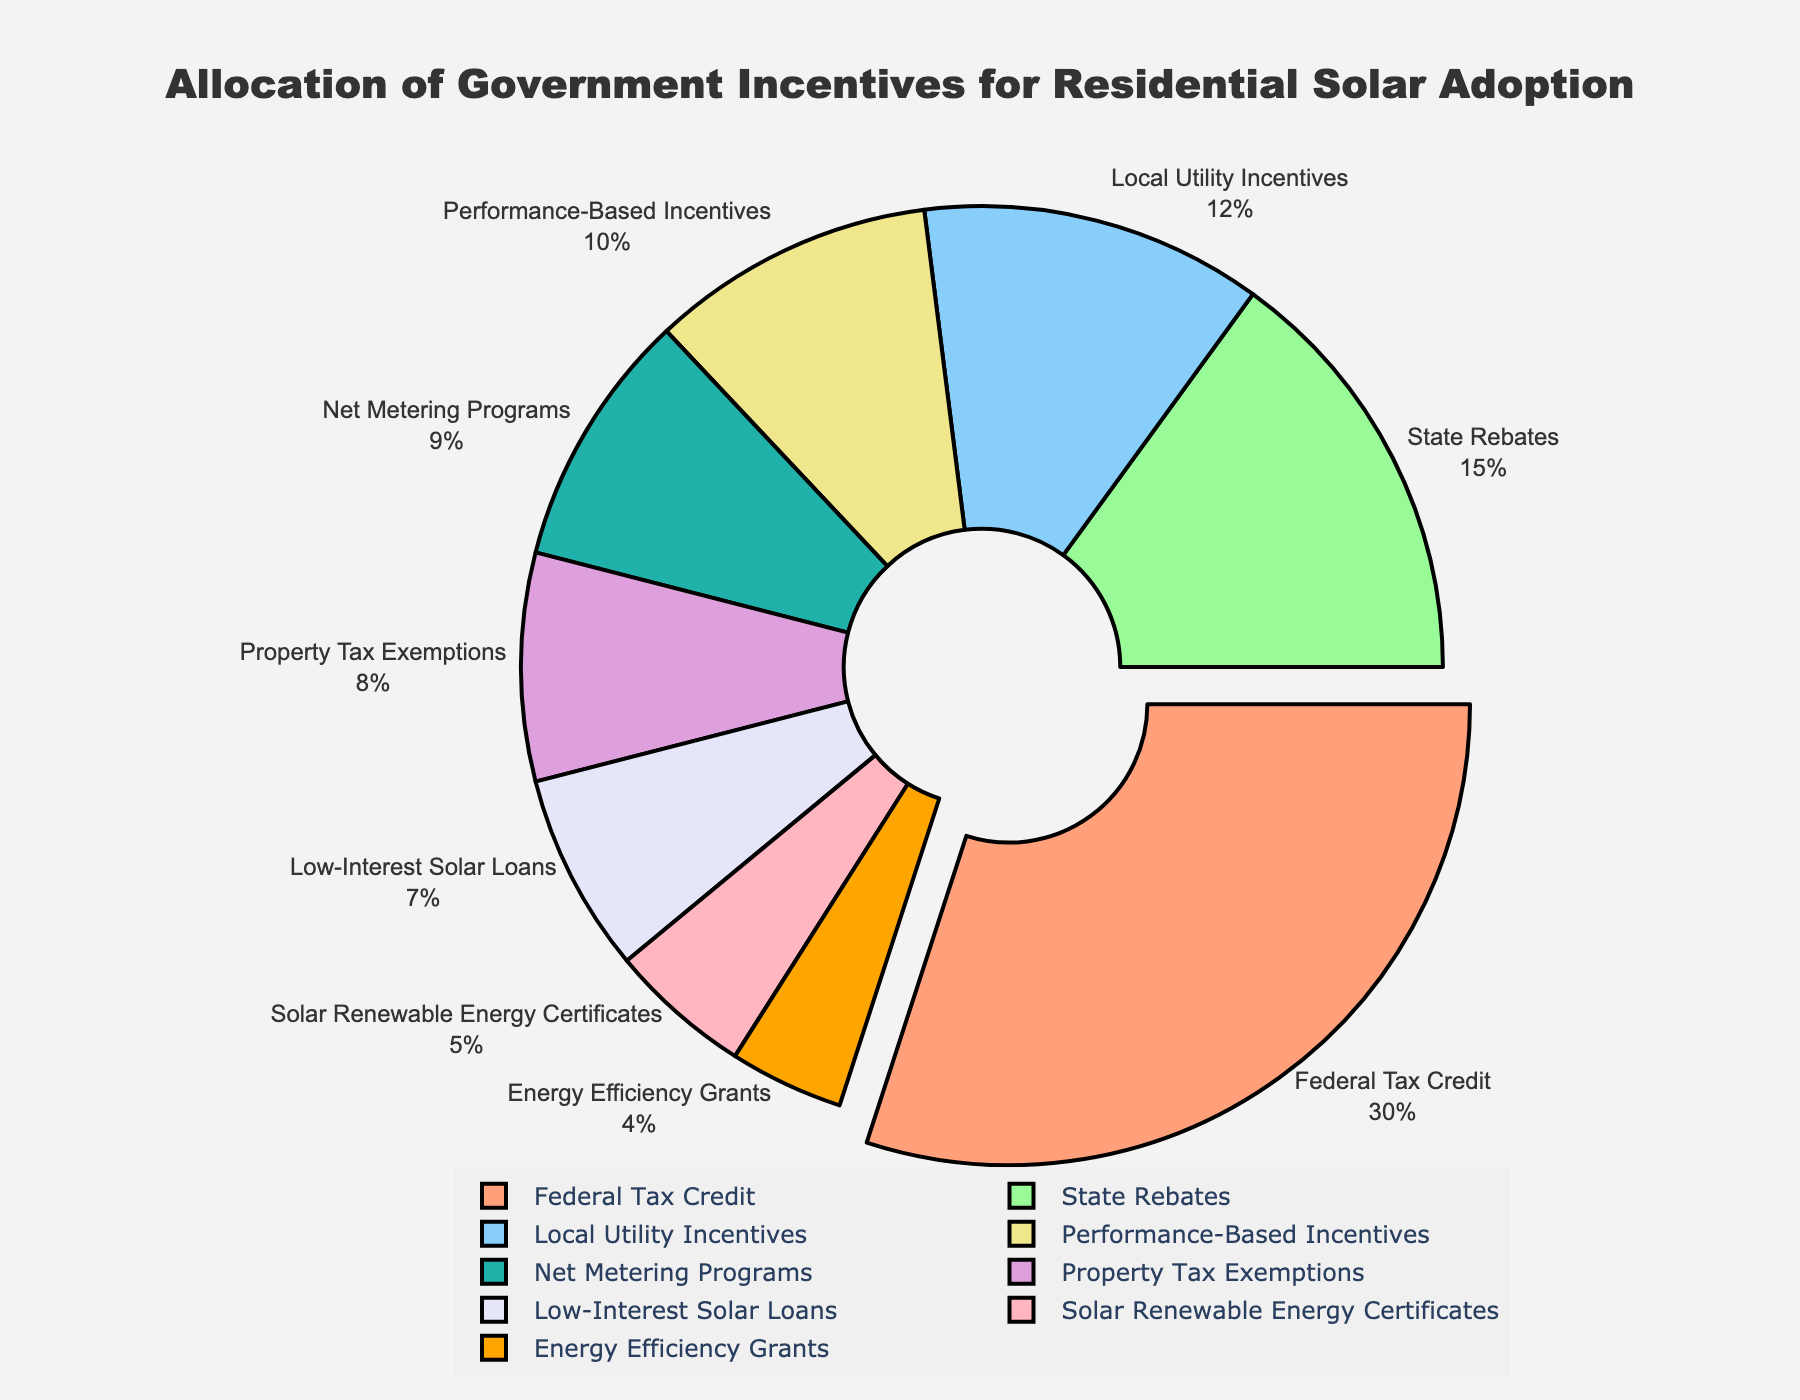What is the largest category in terms of percentage? The Federal Tax Credit has the highest percentage in the pie chart. It is visually distinct as it is slightly pulled out from the pie and has the largest slice.
Answer: Federal Tax Credit What is the total percentage of Federal Tax Credit and State Rebates combined? To find the total, add the percentage of Federal Tax Credit (30%) and State Rebates (15%): 30 + 15 = 45%.
Answer: 45% How does the percentage of Local Utility Incentives compare to Low-Interest Solar Loans? The percentage for Local Utility Incentives is 12%, while for Low-Interest Solar Loans, it is 7%. Since 12% is greater than 7%, Local Utility Incentives has a higher percentage.
Answer: Local Utility Incentives has a higher percentage What are the categories with percentages below 10%? The categories with percentages below 10% are Property Tax Exemptions (8%), Low-Interest Solar Loans (7%), Solar Renewable Energy Certificates (5%), Net Metering Programs (9%), and Energy Efficiency Grants (4%).
Answer: Property Tax Exemptions, Low-Interest Solar Loans, Solar Renewable Energy Certificates, Net Metering Programs, Energy Efficiency Grants Which category occupies the smallest slice of the pie chart? The smallest percentage category is Energy Efficiency Grants, which occupies 4% of the pie chart.
Answer: Energy Efficiency Grants What is the combined percentage of Net Metering Programs and Performance-Based Incentives? To find the combined percentage, add the values for Net Metering Programs (9%) and Performance-Based Incentives (10%): 9 + 10 = 19%.
Answer: 19% How much larger is the State Rebates slice than the Local Utility Incentives slice? The State Rebates slice is 15%, and the Local Utility Incentives slice is 12%. Subtracting these values gives 15 - 12 = 3%.
Answer: 3% Which slice is colored light blue, and what percentage does it represent? The slice colored light blue represents the Local Utility Incentives, which accounts for 12% of the chart.
Answer: Local Utility Incentives, 12% What is the total percentage for the categories under 10% combined? Adding the percentages of Property Tax Exemptions (8%), Low-Interest Solar Loans (7%), Solar Renewable Energy Certificates (5%), Net Metering Programs (9%), and Energy Efficiency Grants (4%): 8 + 7 + 5 + 9 + 4 = 33%.
Answer: 33% If we exclude Federal Tax Credit, what is the new total percentage of the remaining categories? The Federal Tax Credit is 30%. The total percentage of all categories is 100%. Excluding the Federal Tax Credit: 100 - 30 = 70%.
Answer: 70% 